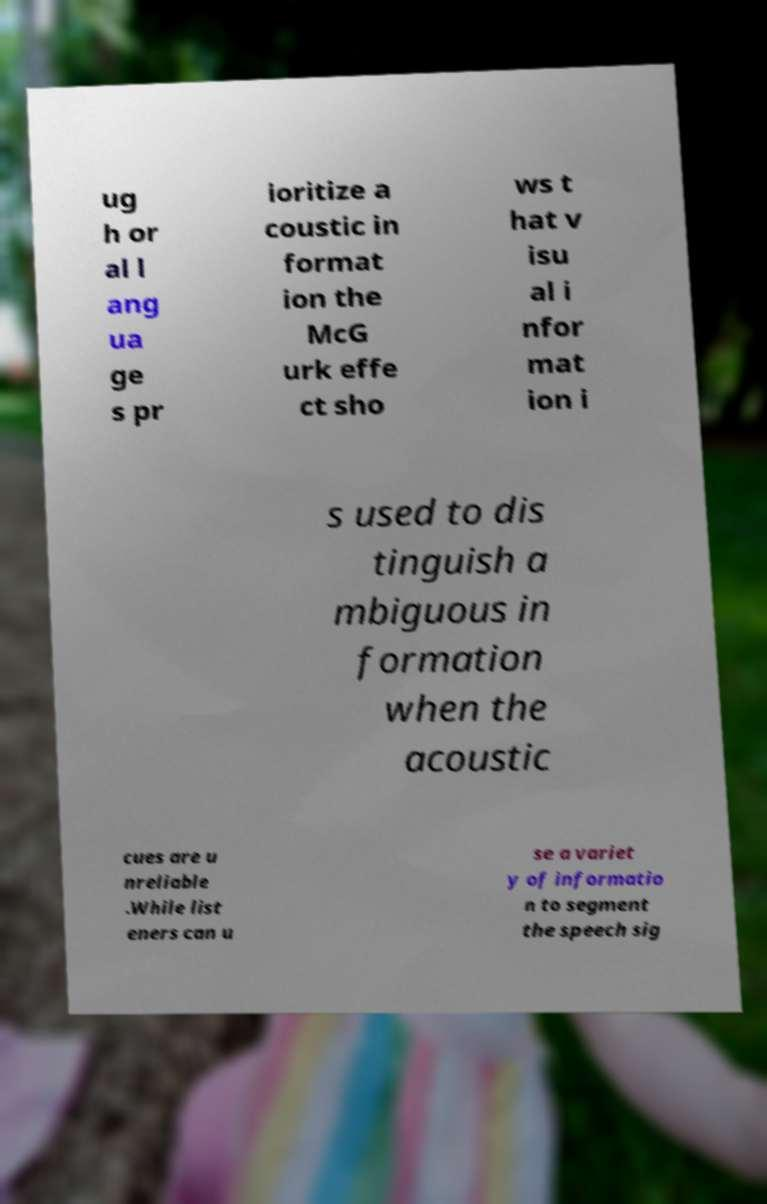I need the written content from this picture converted into text. Can you do that? ug h or al l ang ua ge s pr ioritize a coustic in format ion the McG urk effe ct sho ws t hat v isu al i nfor mat ion i s used to dis tinguish a mbiguous in formation when the acoustic cues are u nreliable .While list eners can u se a variet y of informatio n to segment the speech sig 